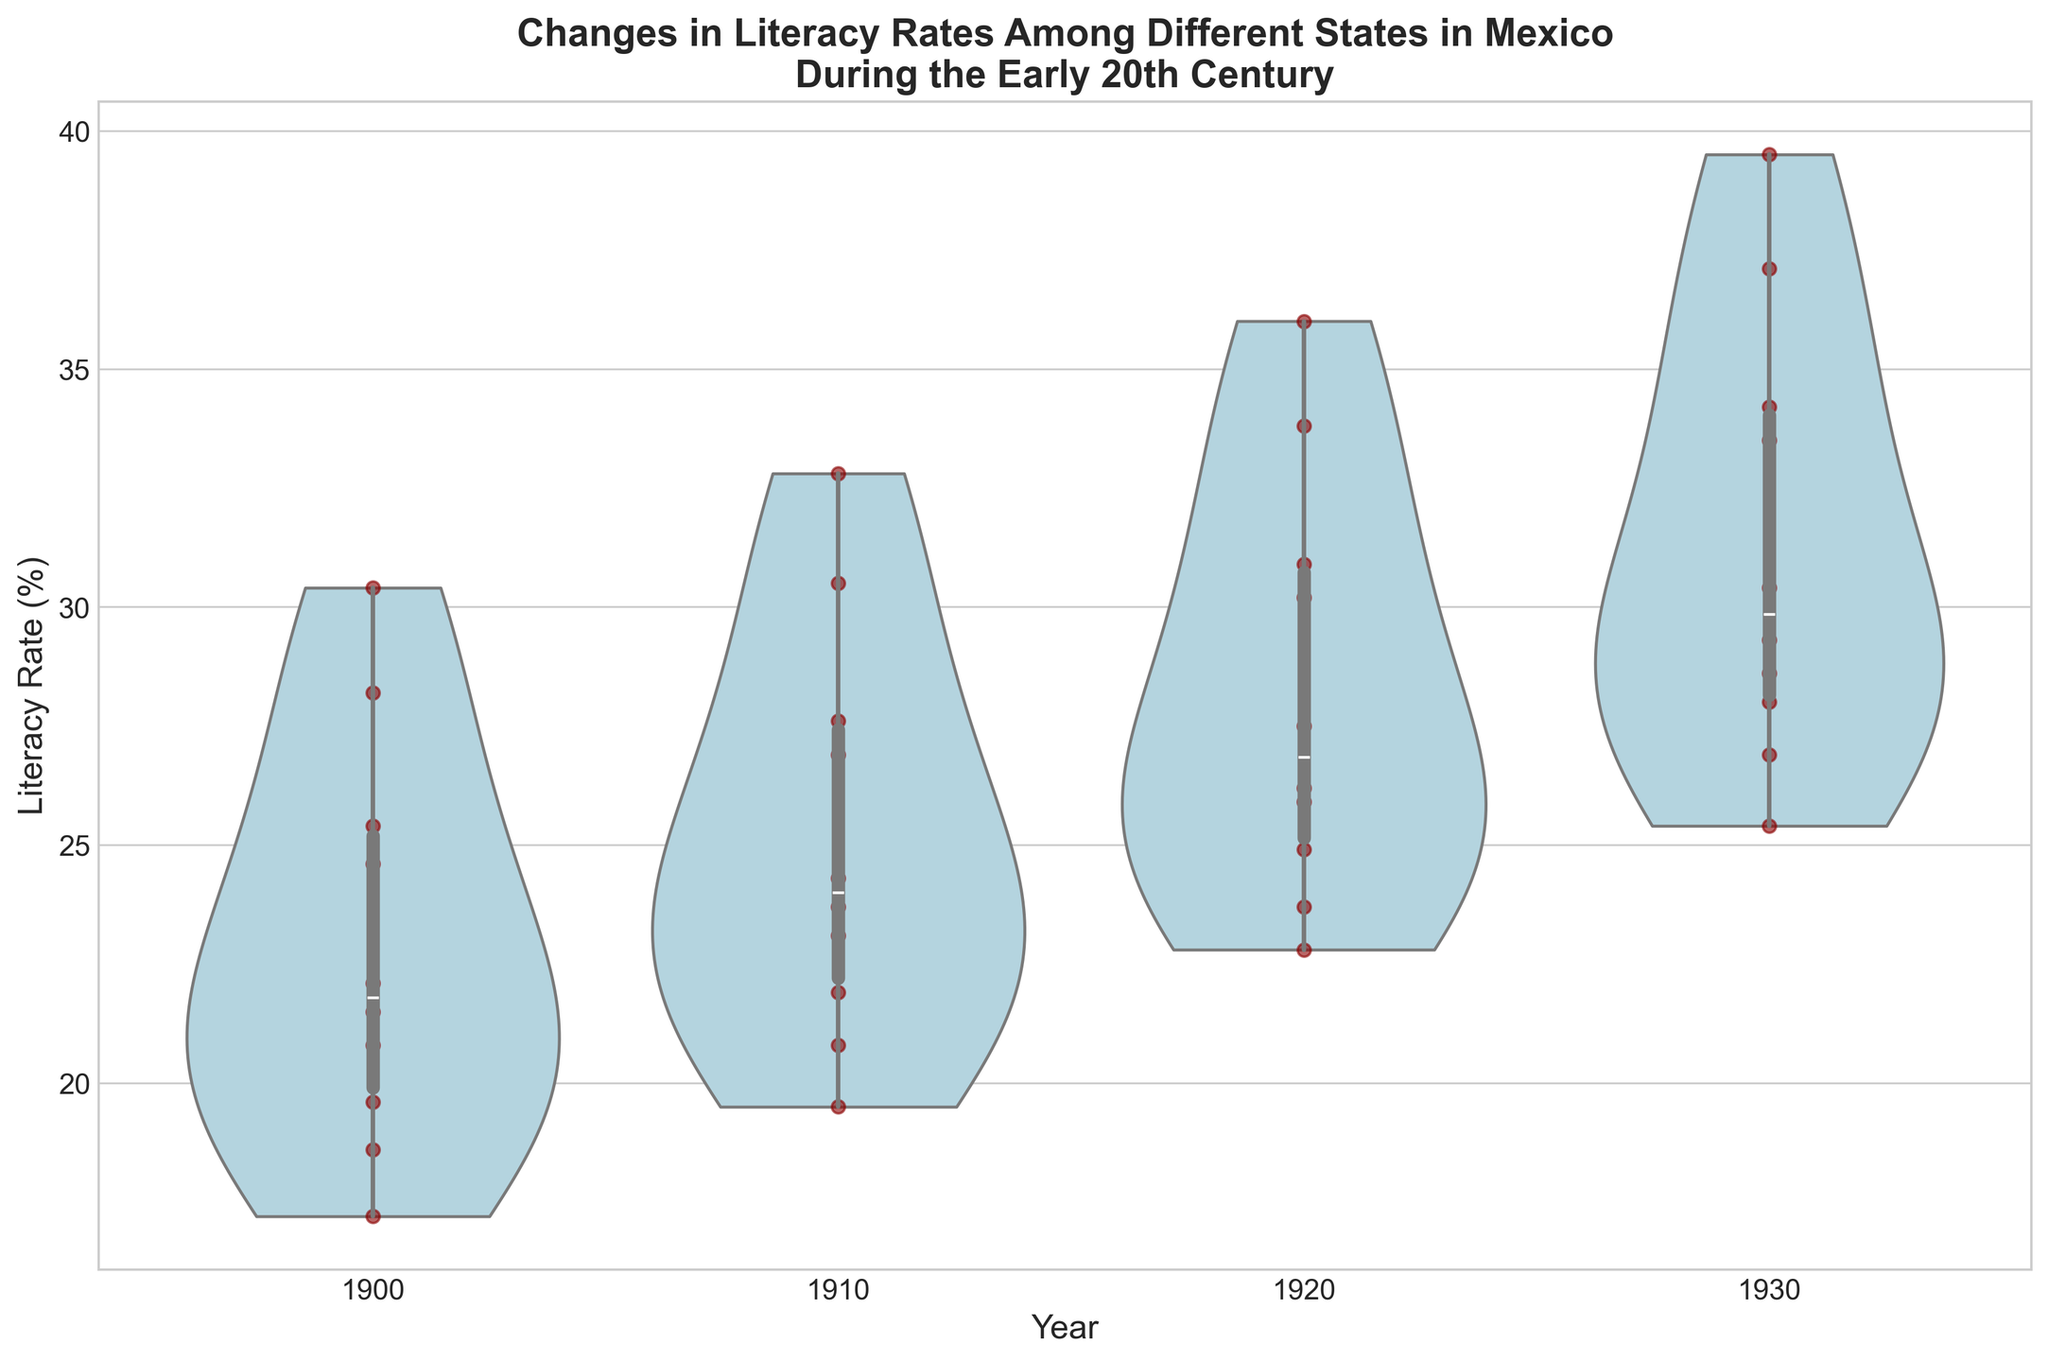What is the title of the plot? The title of the plot is often at the top of the figure and provides a clear summary of the content. Here, the title is 'Changes in Literacy Rates Among Different States in Mexico During the Early 20th Century'.
Answer: Changes in Literacy Rates Among Different States in Mexico During the Early 20th Century Which year has the highest density of states with literacy rates close to 25%? Examine the violin plots for each year and identify where the distribution is most concentrated around 25%. The plot for 1910 shows the widest distribution in this range.
Answer: 1910 How do the median literacy rates change from 1900 to 1930? Identify the medians within the box plots overlayed on each violin plot. The median values increase progressively from 1900 to 1930.
Answer: They increase from 1900 to 1930 Which state had the highest literacy rate in 1930? In the scatter overlay, the uppermost point within the 1930 violin plot represents the highest literacy rate. For 1930, the highest point corresponds to Nuevo León.
Answer: Nuevo León What is the general trend in literacy rates from 1900 to 1930? The overall trend of the violin plots shows a systematic increase in literacy rates across all years from 1900 to 1930, as seen from the upward shift in densities and medians.
Answer: Literacy rates are increasing Between 1910 and 1920, which state's literacy rate improved the most? Compare the points for each state between 1910 and 1920. Jaliscomincreased from 30.5% to 33.8%, showing the greatest improvement.
Answer: Jalisco Are there any outliers in the 1900 literacy rate distribution? Outliers can be identified as points that lie outside the whiskers of the box plot. The 1900 violin plot does not display any points significantly far from the main distribution.
Answer: No What is the range of literacy rates in 1920? The range is the difference between the maximum and minimum points within the 1920 violin plot. The maximum is about 36% and the minimum is approximately 23%.
Answer: About 13% Comparatively, which year has the smallest spread in literacy rates? The spread is indicated by the width of the violin plots; a narrower plot suggests less variation. 1930 appears to have a slightly narrower spread compared to other years.
Answer: 1930 How did the literacy rate for Puebla change from 1900 to 1930? Track the points for Puebla across the years. Puebla's literacy rate increased from 18.6% in 1900 to 26.9% in 1930.
Answer: Increased from 18.6% to 26.9% 